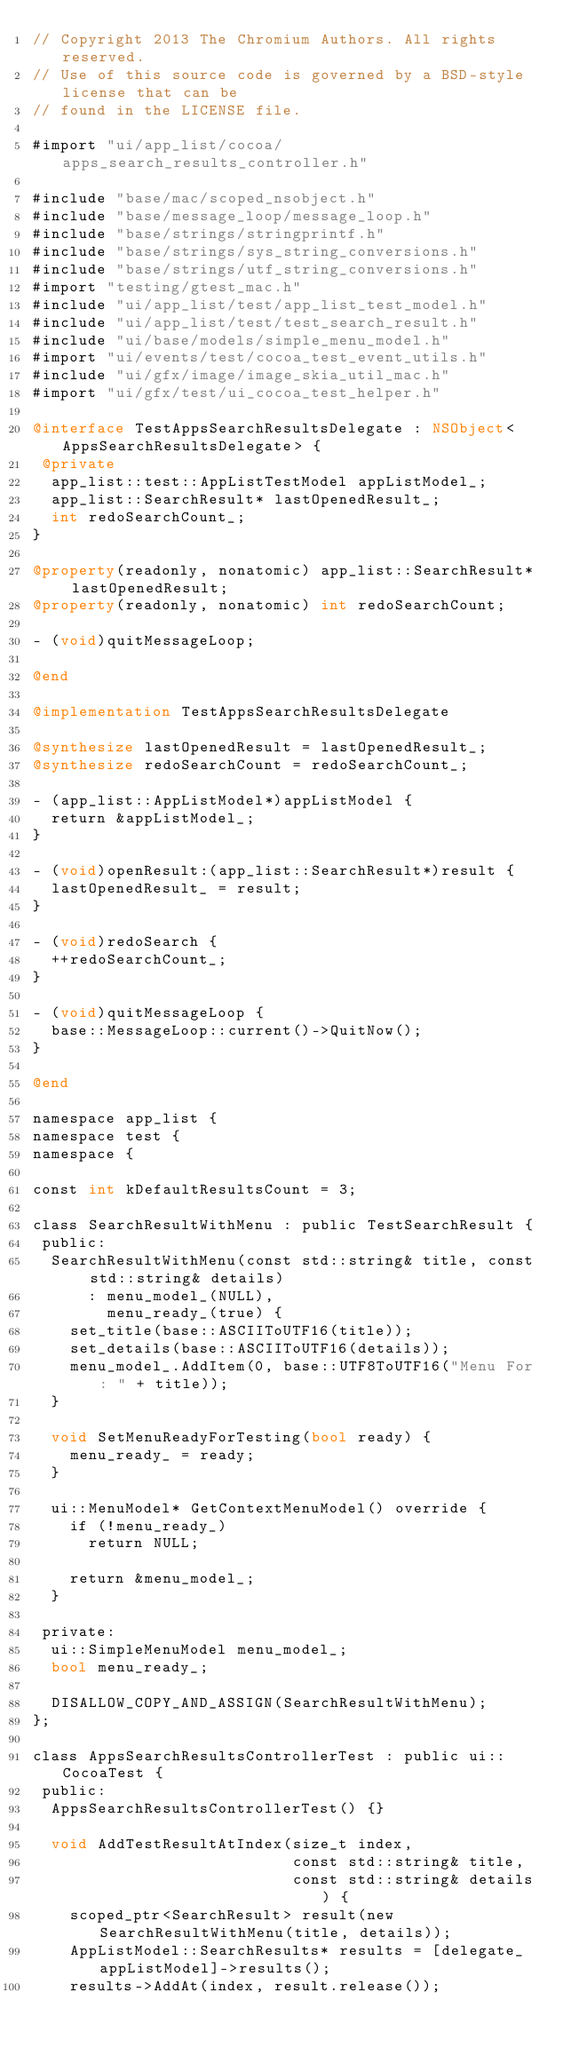<code> <loc_0><loc_0><loc_500><loc_500><_ObjectiveC_>// Copyright 2013 The Chromium Authors. All rights reserved.
// Use of this source code is governed by a BSD-style license that can be
// found in the LICENSE file.

#import "ui/app_list/cocoa/apps_search_results_controller.h"

#include "base/mac/scoped_nsobject.h"
#include "base/message_loop/message_loop.h"
#include "base/strings/stringprintf.h"
#include "base/strings/sys_string_conversions.h"
#include "base/strings/utf_string_conversions.h"
#import "testing/gtest_mac.h"
#include "ui/app_list/test/app_list_test_model.h"
#include "ui/app_list/test/test_search_result.h"
#include "ui/base/models/simple_menu_model.h"
#import "ui/events/test/cocoa_test_event_utils.h"
#include "ui/gfx/image/image_skia_util_mac.h"
#import "ui/gfx/test/ui_cocoa_test_helper.h"

@interface TestAppsSearchResultsDelegate : NSObject<AppsSearchResultsDelegate> {
 @private
  app_list::test::AppListTestModel appListModel_;
  app_list::SearchResult* lastOpenedResult_;
  int redoSearchCount_;
}

@property(readonly, nonatomic) app_list::SearchResult* lastOpenedResult;
@property(readonly, nonatomic) int redoSearchCount;

- (void)quitMessageLoop;

@end

@implementation TestAppsSearchResultsDelegate

@synthesize lastOpenedResult = lastOpenedResult_;
@synthesize redoSearchCount = redoSearchCount_;

- (app_list::AppListModel*)appListModel {
  return &appListModel_;
}

- (void)openResult:(app_list::SearchResult*)result {
  lastOpenedResult_ = result;
}

- (void)redoSearch {
  ++redoSearchCount_;
}

- (void)quitMessageLoop {
  base::MessageLoop::current()->QuitNow();
}

@end

namespace app_list {
namespace test {
namespace {

const int kDefaultResultsCount = 3;

class SearchResultWithMenu : public TestSearchResult {
 public:
  SearchResultWithMenu(const std::string& title, const std::string& details)
      : menu_model_(NULL),
        menu_ready_(true) {
    set_title(base::ASCIIToUTF16(title));
    set_details(base::ASCIIToUTF16(details));
    menu_model_.AddItem(0, base::UTF8ToUTF16("Menu For: " + title));
  }

  void SetMenuReadyForTesting(bool ready) {
    menu_ready_ = ready;
  }

  ui::MenuModel* GetContextMenuModel() override {
    if (!menu_ready_)
      return NULL;

    return &menu_model_;
  }

 private:
  ui::SimpleMenuModel menu_model_;
  bool menu_ready_;

  DISALLOW_COPY_AND_ASSIGN(SearchResultWithMenu);
};

class AppsSearchResultsControllerTest : public ui::CocoaTest {
 public:
  AppsSearchResultsControllerTest() {}

  void AddTestResultAtIndex(size_t index,
                            const std::string& title,
                            const std::string& details) {
    scoped_ptr<SearchResult> result(new SearchResultWithMenu(title, details));
    AppListModel::SearchResults* results = [delegate_ appListModel]->results();
    results->AddAt(index, result.release());</code> 